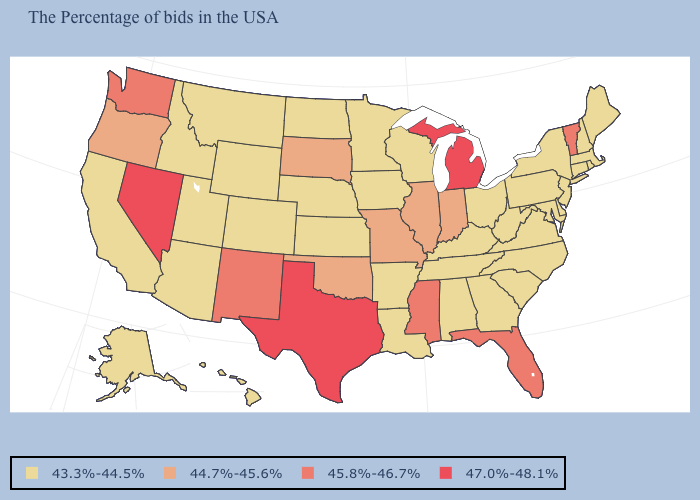Does Nevada have the highest value in the West?
Quick response, please. Yes. Is the legend a continuous bar?
Quick response, please. No. What is the value of Indiana?
Short answer required. 44.7%-45.6%. What is the lowest value in the USA?
Answer briefly. 43.3%-44.5%. Does the map have missing data?
Concise answer only. No. What is the value of Vermont?
Short answer required. 45.8%-46.7%. Name the states that have a value in the range 43.3%-44.5%?
Concise answer only. Maine, Massachusetts, Rhode Island, New Hampshire, Connecticut, New York, New Jersey, Delaware, Maryland, Pennsylvania, Virginia, North Carolina, South Carolina, West Virginia, Ohio, Georgia, Kentucky, Alabama, Tennessee, Wisconsin, Louisiana, Arkansas, Minnesota, Iowa, Kansas, Nebraska, North Dakota, Wyoming, Colorado, Utah, Montana, Arizona, Idaho, California, Alaska, Hawaii. How many symbols are there in the legend?
Short answer required. 4. Does Maine have the lowest value in the USA?
Be succinct. Yes. Which states have the highest value in the USA?
Be succinct. Michigan, Texas, Nevada. Which states hav the highest value in the South?
Be succinct. Texas. Which states have the lowest value in the Northeast?
Keep it brief. Maine, Massachusetts, Rhode Island, New Hampshire, Connecticut, New York, New Jersey, Pennsylvania. Name the states that have a value in the range 44.7%-45.6%?
Quick response, please. Indiana, Illinois, Missouri, Oklahoma, South Dakota, Oregon. Does Kansas have the same value as New Mexico?
Answer briefly. No. 